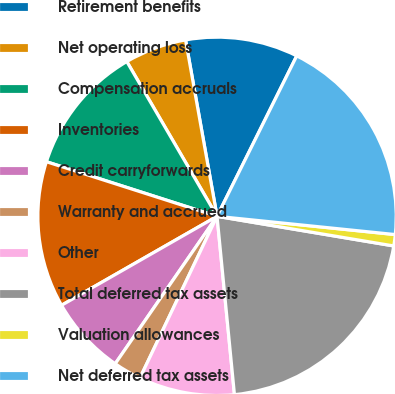Convert chart. <chart><loc_0><loc_0><loc_500><loc_500><pie_chart><fcel>Retirement benefits<fcel>Net operating loss<fcel>Compensation accruals<fcel>Inventories<fcel>Credit carryforwards<fcel>Warranty and accrued<fcel>Other<fcel>Total deferred tax assets<fcel>Valuation allowances<fcel>Net deferred tax assets<nl><fcel>10.15%<fcel>5.59%<fcel>11.67%<fcel>13.2%<fcel>7.11%<fcel>2.54%<fcel>8.63%<fcel>20.81%<fcel>1.02%<fcel>19.29%<nl></chart> 